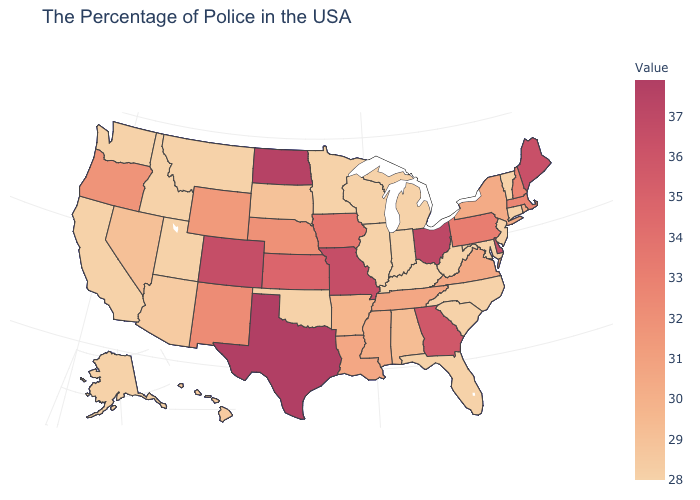Which states have the lowest value in the USA?
Keep it brief. Vermont, Connecticut, New Jersey, Maryland, North Carolina, South Carolina, West Virginia, Florida, Michigan, Kentucky, Indiana, Wisconsin, Illinois, Minnesota, Oklahoma, Utah, Montana, Idaho, California, Washington, Alaska. Which states hav the highest value in the MidWest?
Write a very short answer. North Dakota. Among the states that border Illinois , which have the lowest value?
Write a very short answer. Kentucky, Indiana, Wisconsin. Does Oregon have the lowest value in the USA?
Give a very brief answer. No. 